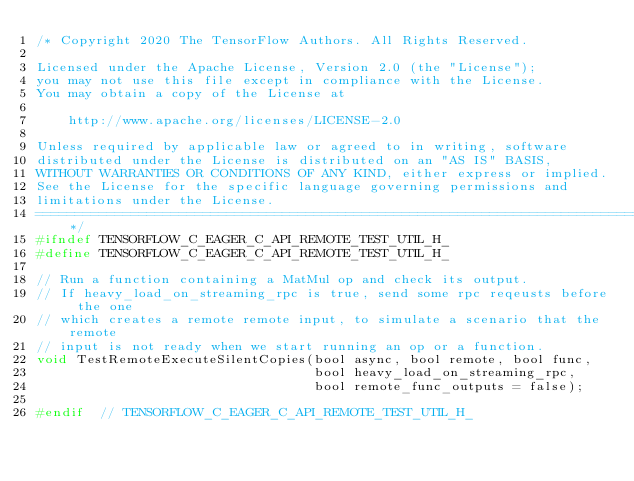Convert code to text. <code><loc_0><loc_0><loc_500><loc_500><_C_>/* Copyright 2020 The TensorFlow Authors. All Rights Reserved.

Licensed under the Apache License, Version 2.0 (the "License");
you may not use this file except in compliance with the License.
You may obtain a copy of the License at

    http://www.apache.org/licenses/LICENSE-2.0

Unless required by applicable law or agreed to in writing, software
distributed under the License is distributed on an "AS IS" BASIS,
WITHOUT WARRANTIES OR CONDITIONS OF ANY KIND, either express or implied.
See the License for the specific language governing permissions and
limitations under the License.
==============================================================================*/
#ifndef TENSORFLOW_C_EAGER_C_API_REMOTE_TEST_UTIL_H_
#define TENSORFLOW_C_EAGER_C_API_REMOTE_TEST_UTIL_H_

// Run a function containing a MatMul op and check its output.
// If heavy_load_on_streaming_rpc is true, send some rpc reqeusts before the one
// which creates a remote remote input, to simulate a scenario that the remote
// input is not ready when we start running an op or a function.
void TestRemoteExecuteSilentCopies(bool async, bool remote, bool func,
                                   bool heavy_load_on_streaming_rpc,
                                   bool remote_func_outputs = false);

#endif  // TENSORFLOW_C_EAGER_C_API_REMOTE_TEST_UTIL_H_
</code> 